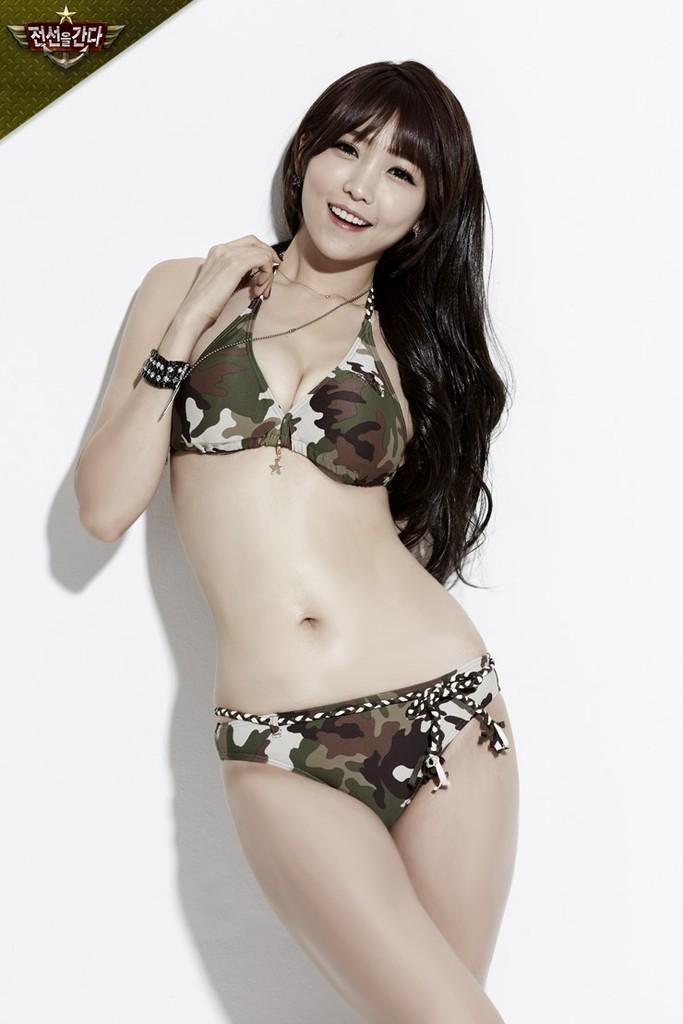Who is the main subject in the image? There is a woman in the image. What is the woman wearing? The woman is wearing a brown, black, and cream-colored dress. What is the woman doing in the image? The woman is standing. What color is the background of the image? The background of the image is white. What type of yarn is the fireman using to spell out letters in the image? There is no fireman, yarn, or letters present in the image. 